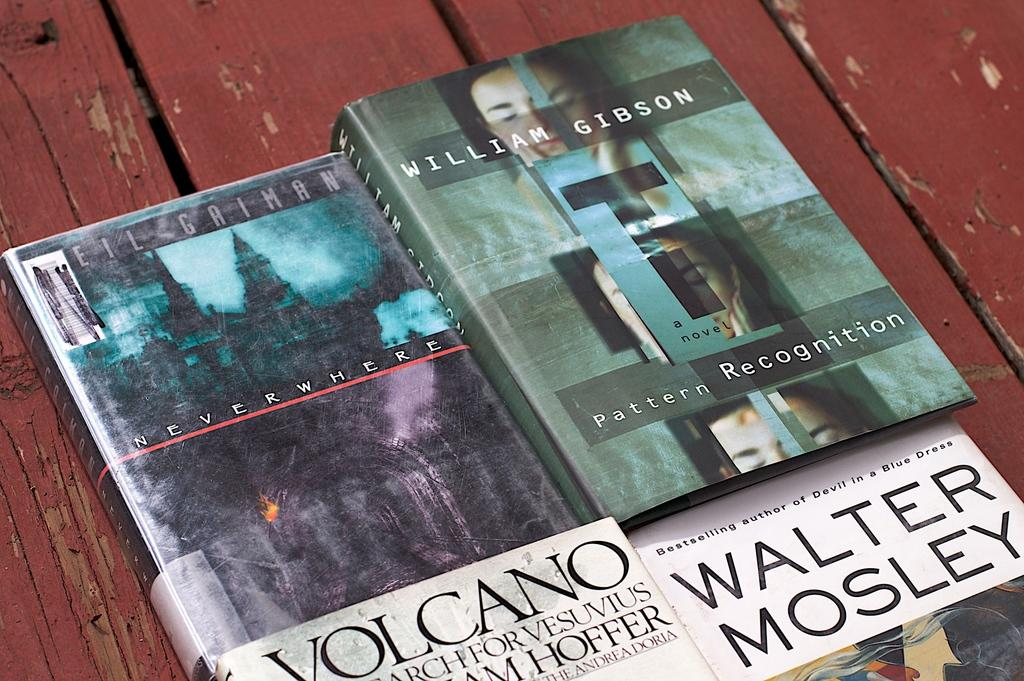<image>
Write a terse but informative summary of the picture. Four books sit on a wooden bench, one of the books is written by William Gibson. 